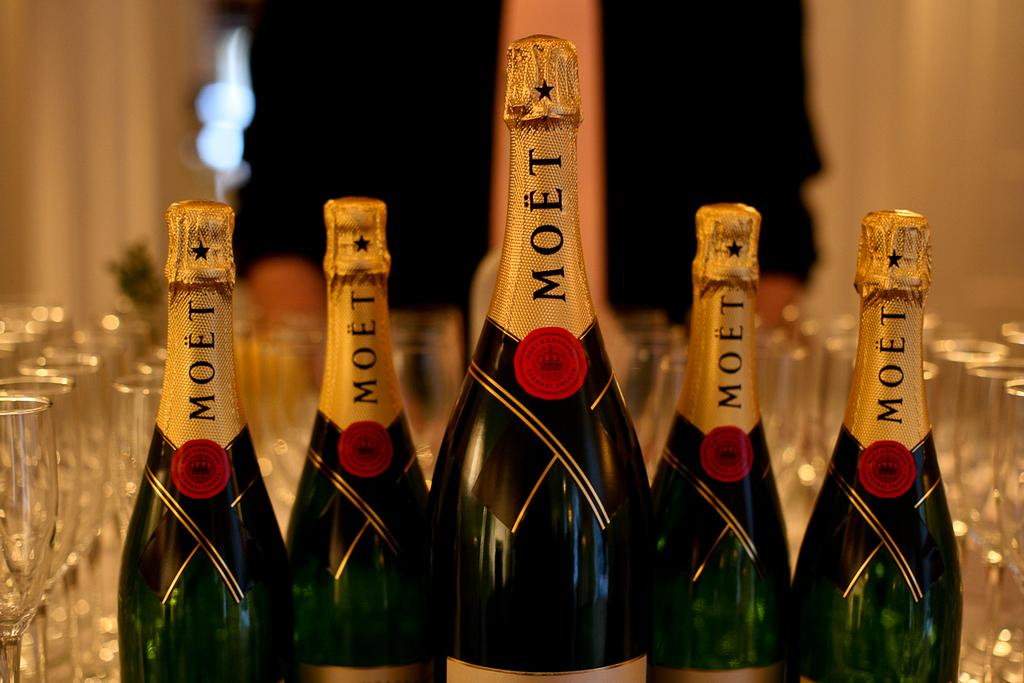<image>
Share a concise interpretation of the image provided. the word moet that is in a wine bottle 